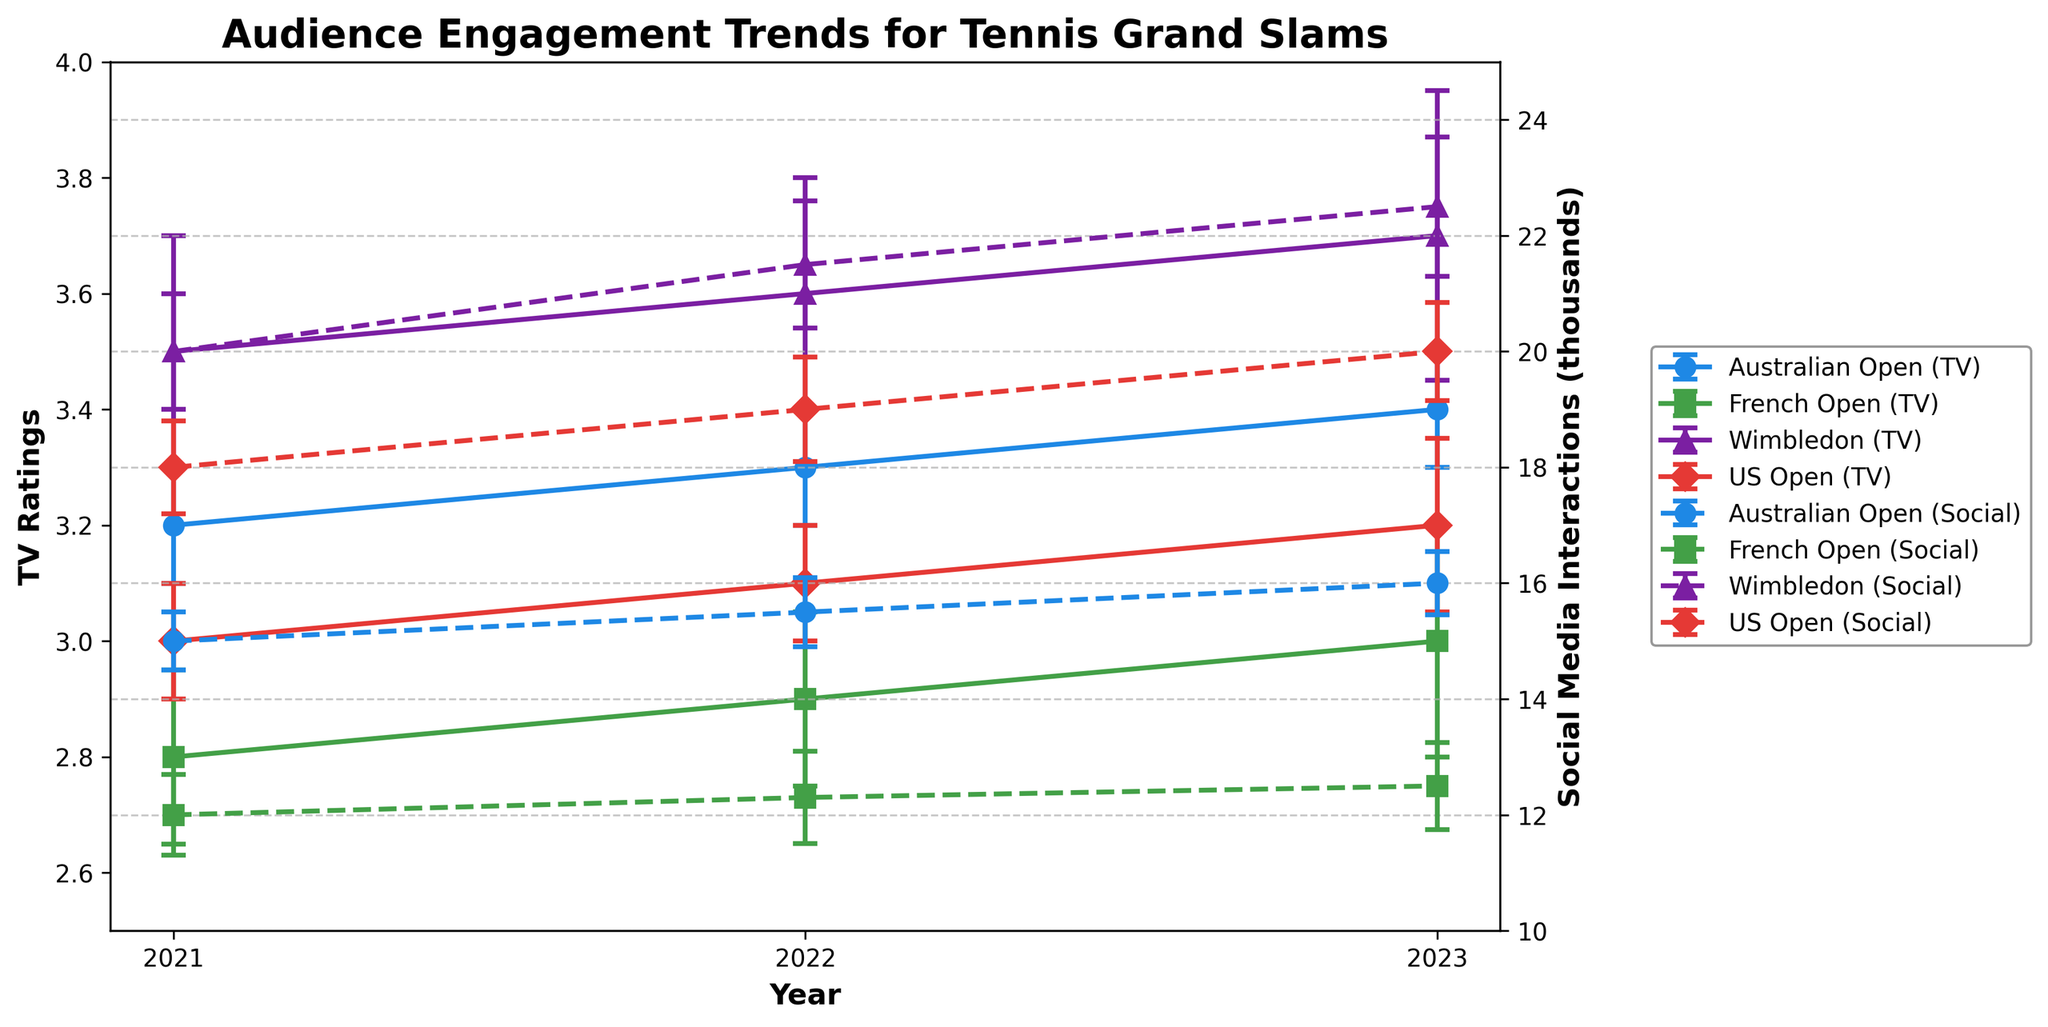What is the title of the figure? The title is usually displayed at the top of the figure and describes the overall theme or subject of the graph. In this case, the title indicates the type of data being shown.
Answer: Audience Engagement Trends for Tennis Grand Slams Which event has the highest TV ratings in 2021? Look at the TV ratings data for the events in 2021 and identify which one has the highest value.
Answer: Wimbledon What is the TV rating for the French Open in 2023 with its error margin? Find the TV rating for the French Open in 2023 on the plot, and add the error margin shown by the error bar.
Answer: 3.0 ± 0.2 How many years of data are displayed in the plot? Count the unique years shown on the x-axis.
Answer: Three (2021, 2022, 2023) Are social media interactions generally higher or lower in July compared to January? Compare the social media interaction data points (converted to thousands) for July and January for the given years.
Answer: Higher Which event shows a consistent increase in social media interactions from 2021 to 2023? Examine the social media interaction trends for each event from 2021 to 2023 to see which one is consistently increasing.
Answer: Wimbledon What is the average TV rating for the Australian Open from 2021 to 2023? Sum the TV ratings for the Australian Open from 2021 to 2023 and divide by the number of years (3).
Answer: (3.2 + 3.3 + 3.4) / 3 = 3.3 By how much did the social media interactions for the US Open increase from 2021 to 2023? Subtract the 2021 value of social media interactions for the US Open from the 2023 value, in thousands.
Answer: 20000 - 18000 = 2000 Which year had the lowest TV ratings for the French Open and what was the rating? Look at the TV ratings for the French Open and identify the year with the lowest value.
Answer: 2021, rating of 2.8 